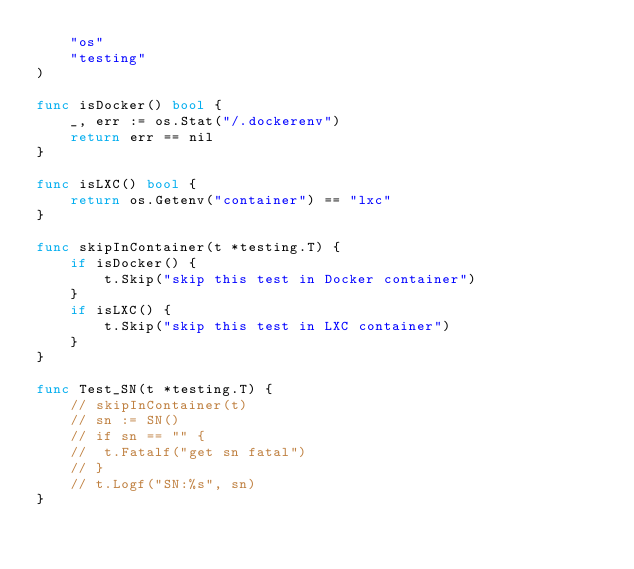<code> <loc_0><loc_0><loc_500><loc_500><_Go_>	"os"
	"testing"
)

func isDocker() bool {
	_, err := os.Stat("/.dockerenv")
	return err == nil
}

func isLXC() bool {
	return os.Getenv("container") == "lxc"
}

func skipInContainer(t *testing.T) {
	if isDocker() {
		t.Skip("skip this test in Docker container")
	}
	if isLXC() {
		t.Skip("skip this test in LXC container")
	}
}

func Test_SN(t *testing.T) {
	// skipInContainer(t)
	// sn := SN()
	// if sn == "" {
	// 	t.Fatalf("get sn fatal")
	// }
	// t.Logf("SN:%s", sn)
}
</code> 